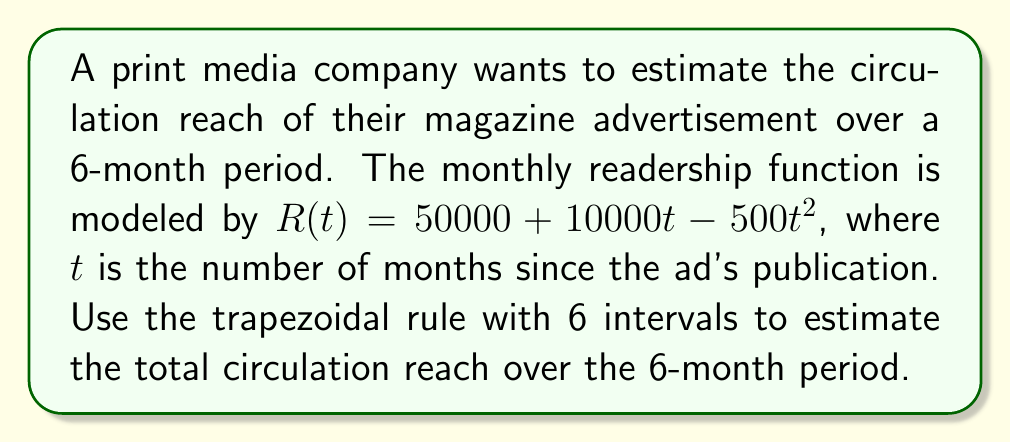Help me with this question. 1) The trapezoidal rule for numerical integration is given by:

   $$\int_{a}^{b} f(x) dx \approx \frac{h}{2} [f(x_0) + 2f(x_1) + 2f(x_2) + ... + 2f(x_{n-1}) + f(x_n)]$$

   where $h = \frac{b-a}{n}$, $n$ is the number of intervals, and $x_i = a + ih$

2) In this case, $a=0$, $b=6$, $n=6$, so $h = \frac{6-0}{6} = 1$

3) Calculate $R(t)$ for $t = 0, 1, 2, 3, 4, 5, 6$:
   
   $R(0) = 50000 + 10000(0) - 500(0)^2 = 50000$
   $R(1) = 50000 + 10000(1) - 500(1)^2 = 59500$
   $R(2) = 50000 + 10000(2) - 500(2)^2 = 68000$
   $R(3) = 50000 + 10000(3) - 500(3)^2 = 75500$
   $R(4) = 50000 + 10000(4) - 500(4)^2 = 82000$
   $R(5) = 50000 + 10000(5) - 500(5)^2 = 87500$
   $R(6) = 50000 + 10000(6) - 500(6)^2 = 92000$

4) Apply the trapezoidal rule:

   $$\text{Total Reach} \approx \frac{1}{2} [50000 + 2(59500 + 68000 + 75500 + 82000 + 87500) + 92000]$$

5) Simplify:
   
   $$\text{Total Reach} \approx \frac{1}{2} [50000 + 745000 + 92000] = \frac{887000}{2} = 443500$$

6) The units are in reader-months, so the total circulation reach over 6 months is approximately 443,500 reader-months.
Answer: 443,500 reader-months 